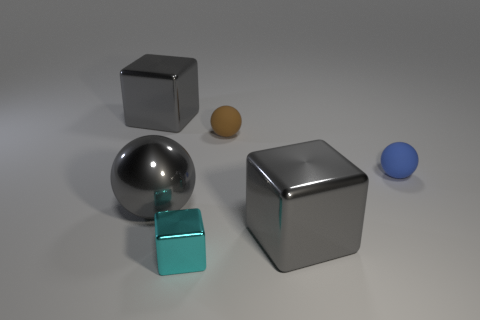Add 3 big gray metallic spheres. How many objects exist? 9 Subtract all small brown rubber things. Subtract all red things. How many objects are left? 5 Add 5 tiny shiny cubes. How many tiny shiny cubes are left? 6 Add 1 big objects. How many big objects exist? 4 Subtract 0 brown cylinders. How many objects are left? 6 